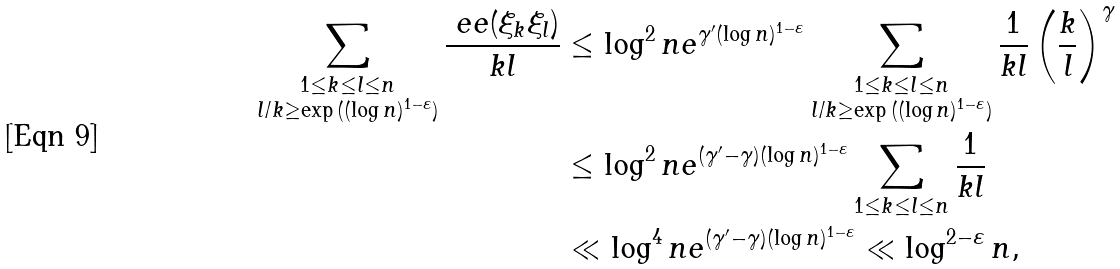Convert formula to latex. <formula><loc_0><loc_0><loc_500><loc_500>\sum _ { \substack { 1 \leq k \leq l \leq n \\ { l } / { k } \geq \exp { ( ( \log n ) ^ { 1 - \varepsilon } ) } } } \frac { \ e e ( \xi _ { k } \xi _ { l } ) } { k l } & \leq \log ^ { 2 } n e ^ { \gamma ^ { \prime } ( \log n ) ^ { 1 - \varepsilon } } \sum _ { \substack { 1 \leq k \leq l \leq n \\ { l } / { k } \geq \exp { ( ( \log n ) ^ { 1 - \varepsilon } ) } } } \frac { 1 } { k l } \left ( \frac { k } { l } \right ) ^ { \gamma } \\ & \leq \log ^ { 2 } n e ^ { ( \gamma ^ { \prime } - \gamma ) ( \log n ) ^ { 1 - \varepsilon } } \sum _ { 1 \leq k \leq l \leq n } \frac { 1 } { k l } \\ & \ll \log ^ { 4 } n e ^ { ( \gamma ^ { \prime } - \gamma ) ( \log n ) ^ { 1 - \varepsilon } } \ll \log ^ { 2 - \varepsilon } n ,</formula> 